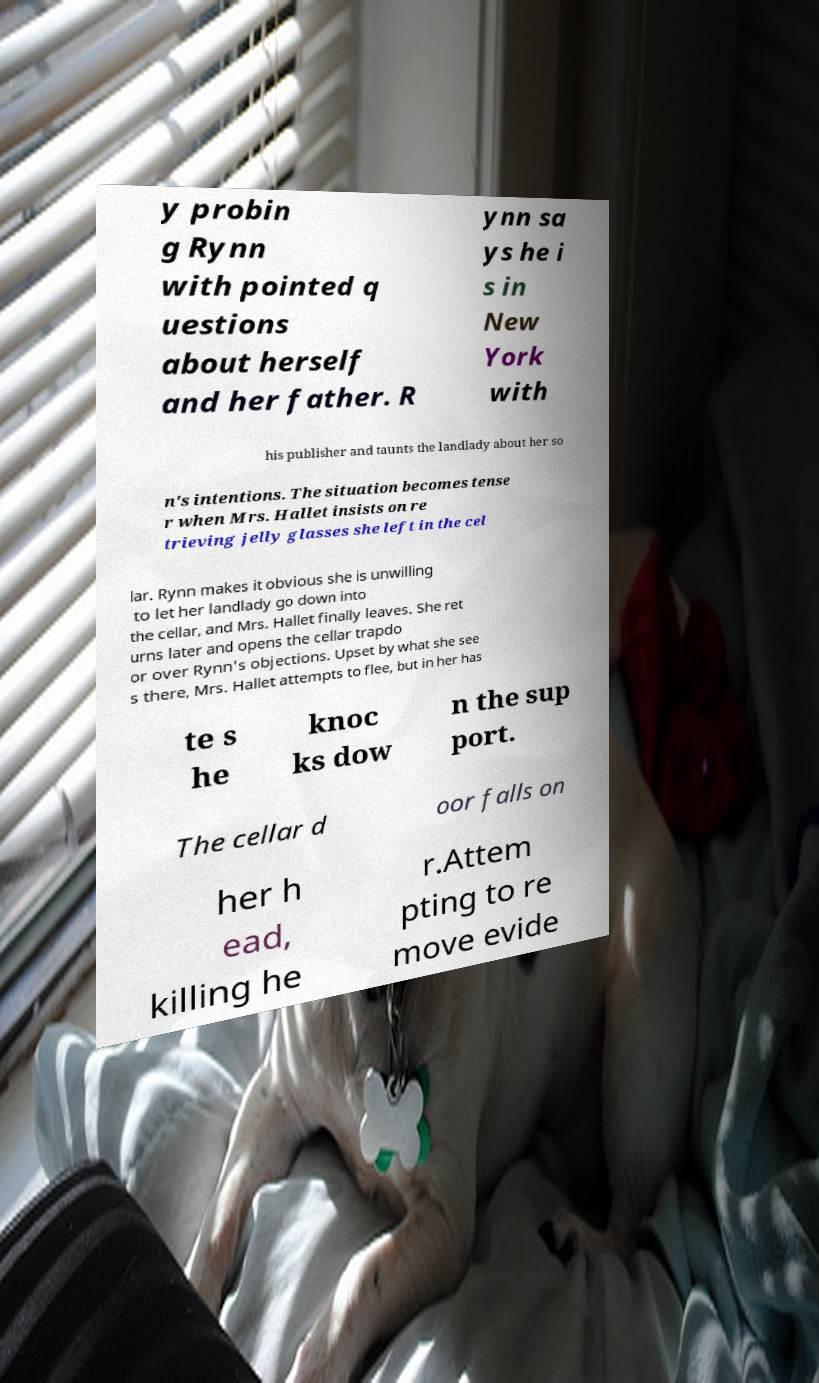Could you assist in decoding the text presented in this image and type it out clearly? y probin g Rynn with pointed q uestions about herself and her father. R ynn sa ys he i s in New York with his publisher and taunts the landlady about her so n's intentions. The situation becomes tense r when Mrs. Hallet insists on re trieving jelly glasses she left in the cel lar. Rynn makes it obvious she is unwilling to let her landlady go down into the cellar, and Mrs. Hallet finally leaves. She ret urns later and opens the cellar trapdo or over Rynn's objections. Upset by what she see s there, Mrs. Hallet attempts to flee, but in her has te s he knoc ks dow n the sup port. The cellar d oor falls on her h ead, killing he r.Attem pting to re move evide 